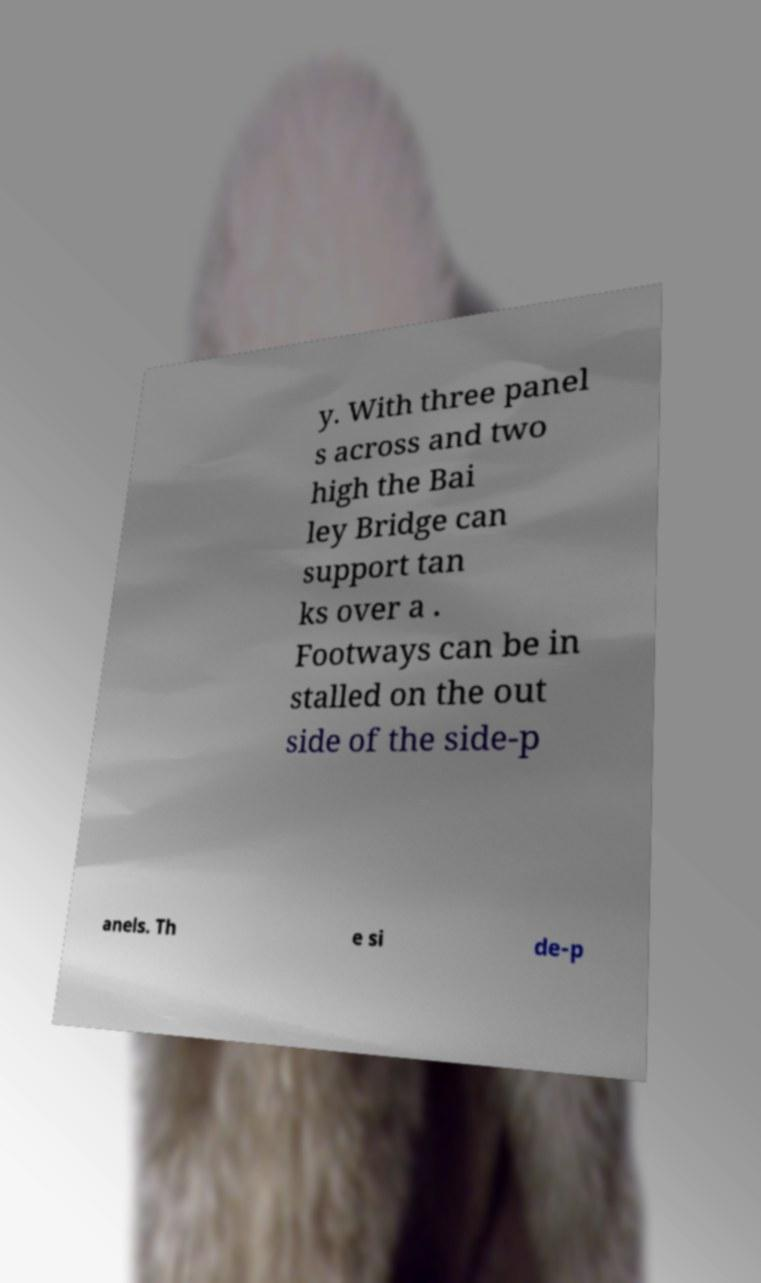Please read and relay the text visible in this image. What does it say? y. With three panel s across and two high the Bai ley Bridge can support tan ks over a . Footways can be in stalled on the out side of the side-p anels. Th e si de-p 